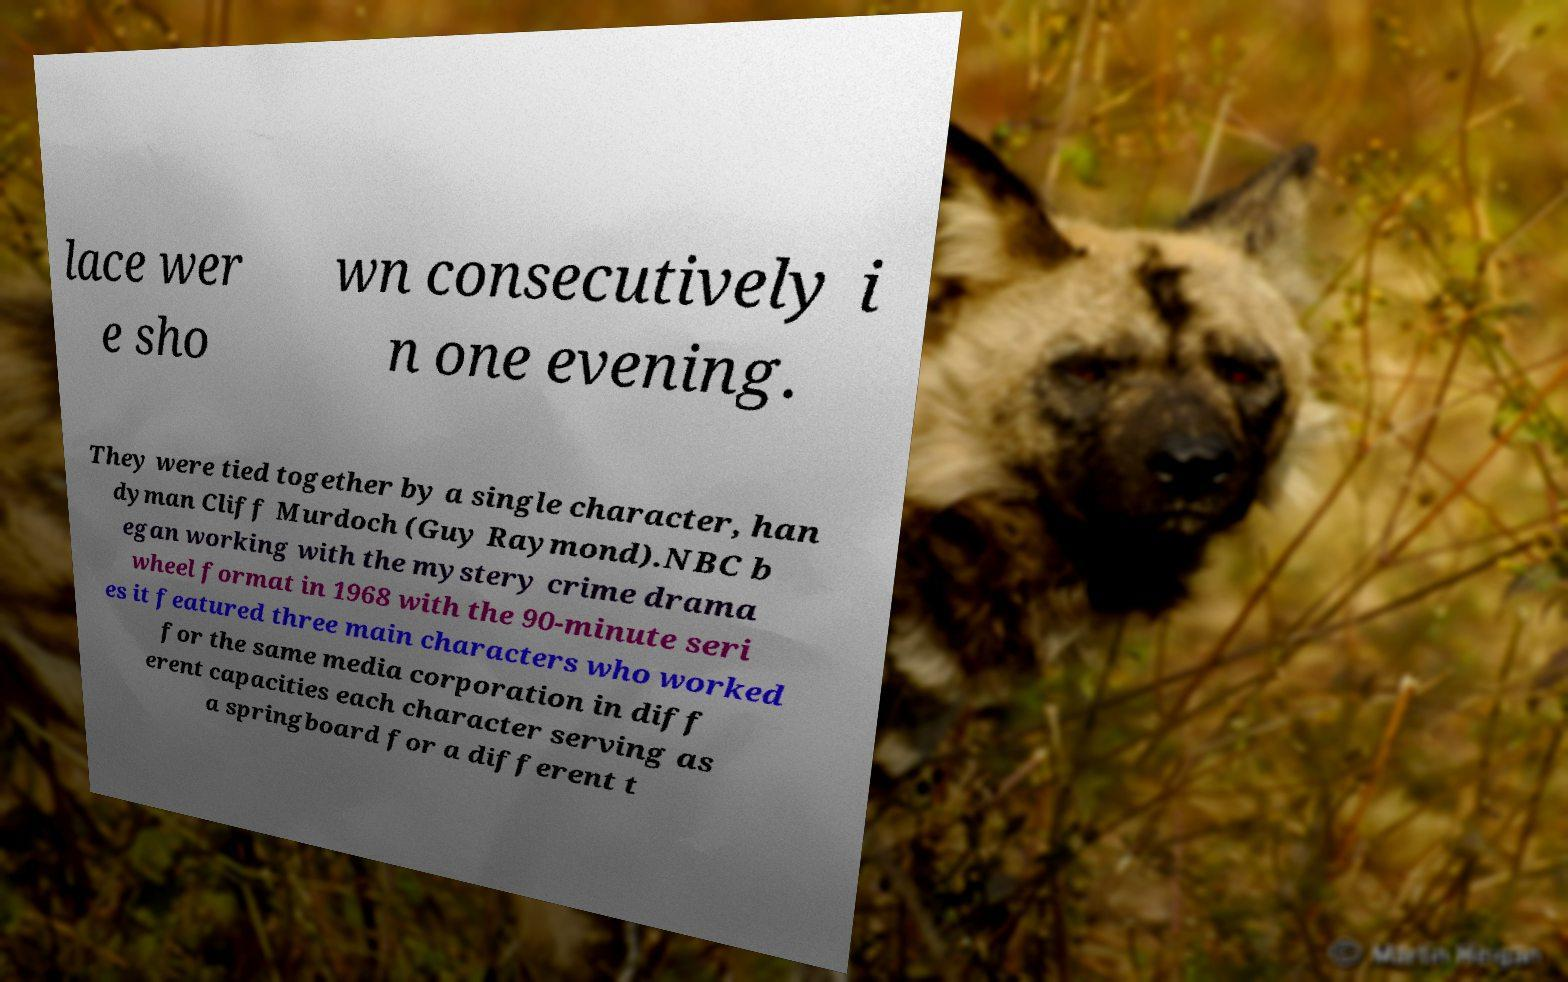Please read and relay the text visible in this image. What does it say? lace wer e sho wn consecutively i n one evening. They were tied together by a single character, han dyman Cliff Murdoch (Guy Raymond).NBC b egan working with the mystery crime drama wheel format in 1968 with the 90-minute seri es it featured three main characters who worked for the same media corporation in diff erent capacities each character serving as a springboard for a different t 